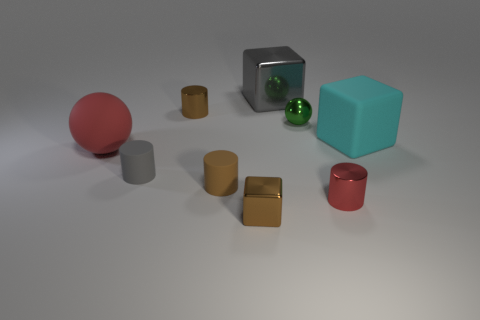There is a cylinder that is the same color as the large ball; what is its size?
Make the answer very short. Small. How many other objects are the same size as the cyan matte cube?
Ensure brevity in your answer.  2. There is a gray object in front of the cyan rubber object; does it have the same size as the gray object behind the cyan rubber object?
Ensure brevity in your answer.  No. Is the number of tiny red metallic cylinders greater than the number of big cubes?
Provide a succinct answer. No. How many large blue objects have the same material as the cyan block?
Your response must be concise. 0. Does the gray rubber object have the same shape as the small brown rubber thing?
Keep it short and to the point. Yes. There is a brown metal object that is in front of the small brown cylinder that is right of the brown metal object that is behind the red metal cylinder; what size is it?
Provide a succinct answer. Small. There is a tiny cylinder that is behind the cyan object; are there any tiny metallic things in front of it?
Provide a succinct answer. Yes. There is a cylinder on the right side of the rubber thing in front of the small gray rubber thing; how many small brown shiny objects are in front of it?
Keep it short and to the point. 1. There is a cube that is both left of the large cyan block and behind the red matte sphere; what is its color?
Your answer should be very brief. Gray. 